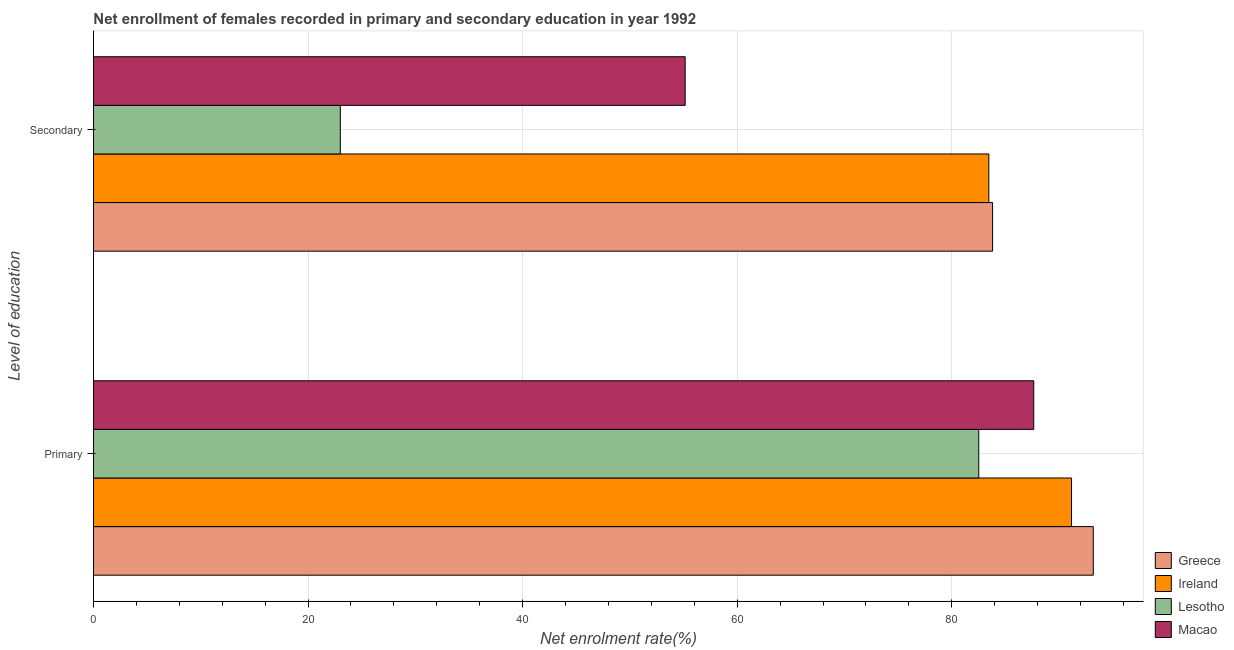How many different coloured bars are there?
Ensure brevity in your answer.  4. Are the number of bars per tick equal to the number of legend labels?
Provide a short and direct response. Yes. How many bars are there on the 1st tick from the top?
Offer a terse response. 4. How many bars are there on the 2nd tick from the bottom?
Make the answer very short. 4. What is the label of the 2nd group of bars from the top?
Give a very brief answer. Primary. What is the enrollment rate in primary education in Ireland?
Offer a very short reply. 91.16. Across all countries, what is the maximum enrollment rate in primary education?
Your response must be concise. 93.19. Across all countries, what is the minimum enrollment rate in secondary education?
Your answer should be compact. 23.01. In which country was the enrollment rate in primary education minimum?
Ensure brevity in your answer.  Lesotho. What is the total enrollment rate in secondary education in the graph?
Your answer should be very brief. 245.42. What is the difference between the enrollment rate in secondary education in Ireland and that in Lesotho?
Your answer should be very brief. 60.45. What is the difference between the enrollment rate in primary education in Ireland and the enrollment rate in secondary education in Greece?
Offer a very short reply. 7.36. What is the average enrollment rate in primary education per country?
Provide a succinct answer. 88.63. What is the difference between the enrollment rate in secondary education and enrollment rate in primary education in Lesotho?
Offer a terse response. -59.51. What is the ratio of the enrollment rate in secondary education in Lesotho to that in Greece?
Provide a succinct answer. 0.27. What does the 3rd bar from the top in Primary represents?
Your answer should be compact. Ireland. What does the 3rd bar from the bottom in Secondary represents?
Offer a terse response. Lesotho. What is the title of the graph?
Your answer should be compact. Net enrollment of females recorded in primary and secondary education in year 1992. Does "Togo" appear as one of the legend labels in the graph?
Your answer should be very brief. No. What is the label or title of the X-axis?
Your answer should be compact. Net enrolment rate(%). What is the label or title of the Y-axis?
Your answer should be compact. Level of education. What is the Net enrolment rate(%) of Greece in Primary?
Offer a terse response. 93.19. What is the Net enrolment rate(%) of Ireland in Primary?
Provide a succinct answer. 91.16. What is the Net enrolment rate(%) in Lesotho in Primary?
Ensure brevity in your answer.  82.52. What is the Net enrolment rate(%) of Macao in Primary?
Keep it short and to the point. 87.64. What is the Net enrolment rate(%) of Greece in Secondary?
Offer a very short reply. 83.81. What is the Net enrolment rate(%) of Ireland in Secondary?
Your response must be concise. 83.46. What is the Net enrolment rate(%) in Lesotho in Secondary?
Provide a succinct answer. 23.01. What is the Net enrolment rate(%) of Macao in Secondary?
Keep it short and to the point. 55.15. Across all Level of education, what is the maximum Net enrolment rate(%) of Greece?
Your response must be concise. 93.19. Across all Level of education, what is the maximum Net enrolment rate(%) of Ireland?
Give a very brief answer. 91.16. Across all Level of education, what is the maximum Net enrolment rate(%) of Lesotho?
Your answer should be very brief. 82.52. Across all Level of education, what is the maximum Net enrolment rate(%) of Macao?
Keep it short and to the point. 87.64. Across all Level of education, what is the minimum Net enrolment rate(%) of Greece?
Your answer should be very brief. 83.81. Across all Level of education, what is the minimum Net enrolment rate(%) of Ireland?
Ensure brevity in your answer.  83.46. Across all Level of education, what is the minimum Net enrolment rate(%) of Lesotho?
Offer a very short reply. 23.01. Across all Level of education, what is the minimum Net enrolment rate(%) in Macao?
Give a very brief answer. 55.15. What is the total Net enrolment rate(%) of Greece in the graph?
Your response must be concise. 177. What is the total Net enrolment rate(%) in Ireland in the graph?
Your answer should be very brief. 174.62. What is the total Net enrolment rate(%) in Lesotho in the graph?
Your answer should be very brief. 105.52. What is the total Net enrolment rate(%) of Macao in the graph?
Your answer should be very brief. 142.79. What is the difference between the Net enrolment rate(%) in Greece in Primary and that in Secondary?
Your answer should be very brief. 9.39. What is the difference between the Net enrolment rate(%) in Ireland in Primary and that in Secondary?
Keep it short and to the point. 7.71. What is the difference between the Net enrolment rate(%) in Lesotho in Primary and that in Secondary?
Ensure brevity in your answer.  59.51. What is the difference between the Net enrolment rate(%) in Macao in Primary and that in Secondary?
Keep it short and to the point. 32.49. What is the difference between the Net enrolment rate(%) of Greece in Primary and the Net enrolment rate(%) of Ireland in Secondary?
Your answer should be very brief. 9.74. What is the difference between the Net enrolment rate(%) of Greece in Primary and the Net enrolment rate(%) of Lesotho in Secondary?
Offer a terse response. 70.19. What is the difference between the Net enrolment rate(%) in Greece in Primary and the Net enrolment rate(%) in Macao in Secondary?
Offer a very short reply. 38.04. What is the difference between the Net enrolment rate(%) of Ireland in Primary and the Net enrolment rate(%) of Lesotho in Secondary?
Your response must be concise. 68.16. What is the difference between the Net enrolment rate(%) of Ireland in Primary and the Net enrolment rate(%) of Macao in Secondary?
Ensure brevity in your answer.  36.01. What is the difference between the Net enrolment rate(%) in Lesotho in Primary and the Net enrolment rate(%) in Macao in Secondary?
Your response must be concise. 27.37. What is the average Net enrolment rate(%) of Greece per Level of education?
Offer a terse response. 88.5. What is the average Net enrolment rate(%) in Ireland per Level of education?
Make the answer very short. 87.31. What is the average Net enrolment rate(%) of Lesotho per Level of education?
Your answer should be very brief. 52.76. What is the average Net enrolment rate(%) in Macao per Level of education?
Make the answer very short. 71.4. What is the difference between the Net enrolment rate(%) in Greece and Net enrolment rate(%) in Ireland in Primary?
Provide a short and direct response. 2.03. What is the difference between the Net enrolment rate(%) in Greece and Net enrolment rate(%) in Lesotho in Primary?
Keep it short and to the point. 10.68. What is the difference between the Net enrolment rate(%) in Greece and Net enrolment rate(%) in Macao in Primary?
Ensure brevity in your answer.  5.55. What is the difference between the Net enrolment rate(%) in Ireland and Net enrolment rate(%) in Lesotho in Primary?
Ensure brevity in your answer.  8.65. What is the difference between the Net enrolment rate(%) in Ireland and Net enrolment rate(%) in Macao in Primary?
Provide a short and direct response. 3.52. What is the difference between the Net enrolment rate(%) of Lesotho and Net enrolment rate(%) of Macao in Primary?
Make the answer very short. -5.12. What is the difference between the Net enrolment rate(%) of Greece and Net enrolment rate(%) of Ireland in Secondary?
Give a very brief answer. 0.35. What is the difference between the Net enrolment rate(%) of Greece and Net enrolment rate(%) of Lesotho in Secondary?
Give a very brief answer. 60.8. What is the difference between the Net enrolment rate(%) in Greece and Net enrolment rate(%) in Macao in Secondary?
Ensure brevity in your answer.  28.66. What is the difference between the Net enrolment rate(%) in Ireland and Net enrolment rate(%) in Lesotho in Secondary?
Your response must be concise. 60.45. What is the difference between the Net enrolment rate(%) in Ireland and Net enrolment rate(%) in Macao in Secondary?
Your response must be concise. 28.3. What is the difference between the Net enrolment rate(%) of Lesotho and Net enrolment rate(%) of Macao in Secondary?
Your response must be concise. -32.14. What is the ratio of the Net enrolment rate(%) in Greece in Primary to that in Secondary?
Offer a very short reply. 1.11. What is the ratio of the Net enrolment rate(%) in Ireland in Primary to that in Secondary?
Keep it short and to the point. 1.09. What is the ratio of the Net enrolment rate(%) of Lesotho in Primary to that in Secondary?
Provide a short and direct response. 3.59. What is the ratio of the Net enrolment rate(%) of Macao in Primary to that in Secondary?
Keep it short and to the point. 1.59. What is the difference between the highest and the second highest Net enrolment rate(%) in Greece?
Make the answer very short. 9.39. What is the difference between the highest and the second highest Net enrolment rate(%) of Ireland?
Your response must be concise. 7.71. What is the difference between the highest and the second highest Net enrolment rate(%) of Lesotho?
Offer a very short reply. 59.51. What is the difference between the highest and the second highest Net enrolment rate(%) in Macao?
Offer a terse response. 32.49. What is the difference between the highest and the lowest Net enrolment rate(%) of Greece?
Your response must be concise. 9.39. What is the difference between the highest and the lowest Net enrolment rate(%) of Ireland?
Provide a short and direct response. 7.71. What is the difference between the highest and the lowest Net enrolment rate(%) of Lesotho?
Your answer should be compact. 59.51. What is the difference between the highest and the lowest Net enrolment rate(%) of Macao?
Provide a succinct answer. 32.49. 